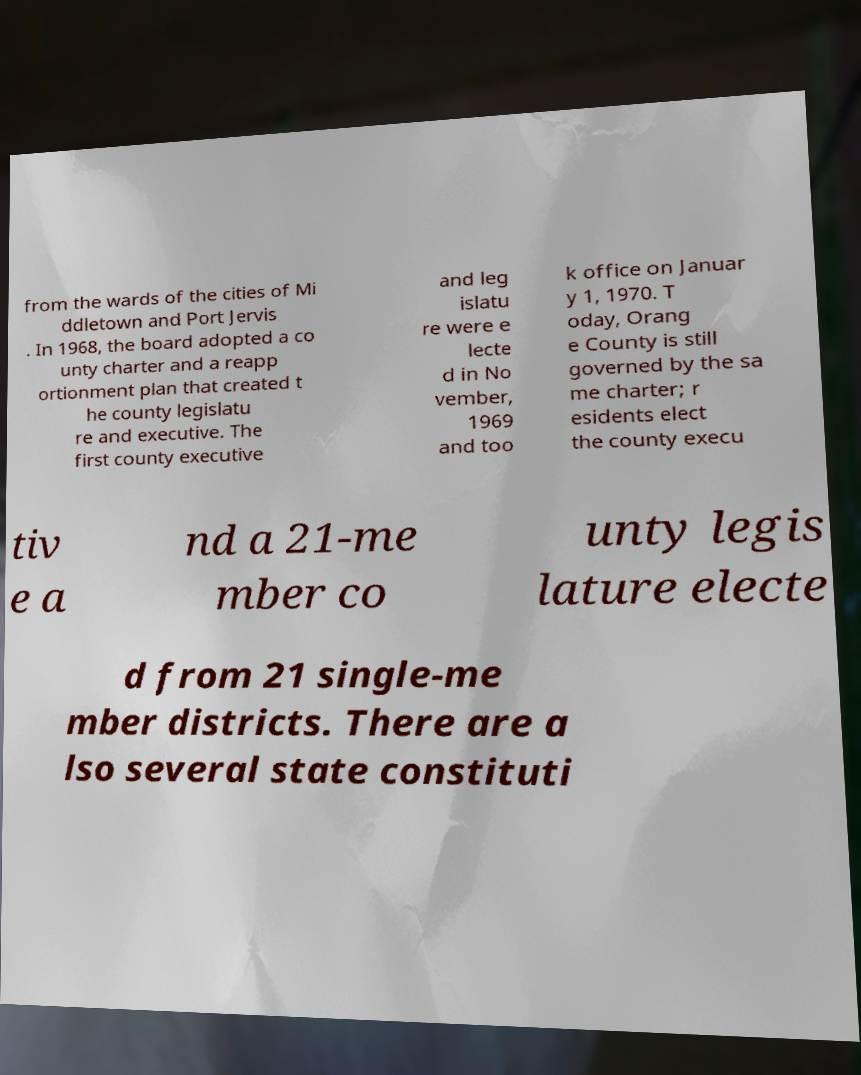There's text embedded in this image that I need extracted. Can you transcribe it verbatim? from the wards of the cities of Mi ddletown and Port Jervis . In 1968, the board adopted a co unty charter and a reapp ortionment plan that created t he county legislatu re and executive. The first county executive and leg islatu re were e lecte d in No vember, 1969 and too k office on Januar y 1, 1970. T oday, Orang e County is still governed by the sa me charter; r esidents elect the county execu tiv e a nd a 21-me mber co unty legis lature electe d from 21 single-me mber districts. There are a lso several state constituti 